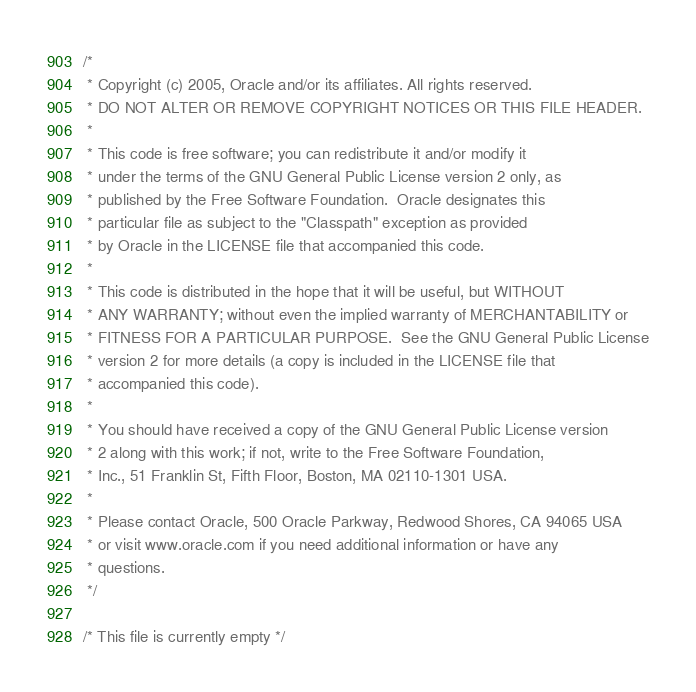Convert code to text. <code><loc_0><loc_0><loc_500><loc_500><_C_>/*
 * Copyright (c) 2005, Oracle and/or its affiliates. All rights reserved.
 * DO NOT ALTER OR REMOVE COPYRIGHT NOTICES OR THIS FILE HEADER.
 *
 * This code is free software; you can redistribute it and/or modify it
 * under the terms of the GNU General Public License version 2 only, as
 * published by the Free Software Foundation.  Oracle designates this
 * particular file as subject to the "Classpath" exception as provided
 * by Oracle in the LICENSE file that accompanied this code.
 *
 * This code is distributed in the hope that it will be useful, but WITHOUT
 * ANY WARRANTY; without even the implied warranty of MERCHANTABILITY or
 * FITNESS FOR A PARTICULAR PURPOSE.  See the GNU General Public License
 * version 2 for more details (a copy is included in the LICENSE file that
 * accompanied this code).
 *
 * You should have received a copy of the GNU General Public License version
 * 2 along with this work; if not, write to the Free Software Foundation,
 * Inc., 51 Franklin St, Fifth Floor, Boston, MA 02110-1301 USA.
 *
 * Please contact Oracle, 500 Oracle Parkway, Redwood Shores, CA 94065 USA
 * or visit www.oracle.com if you need additional information or have any
 * questions.
 */

/* This file is currently empty */
</code> 